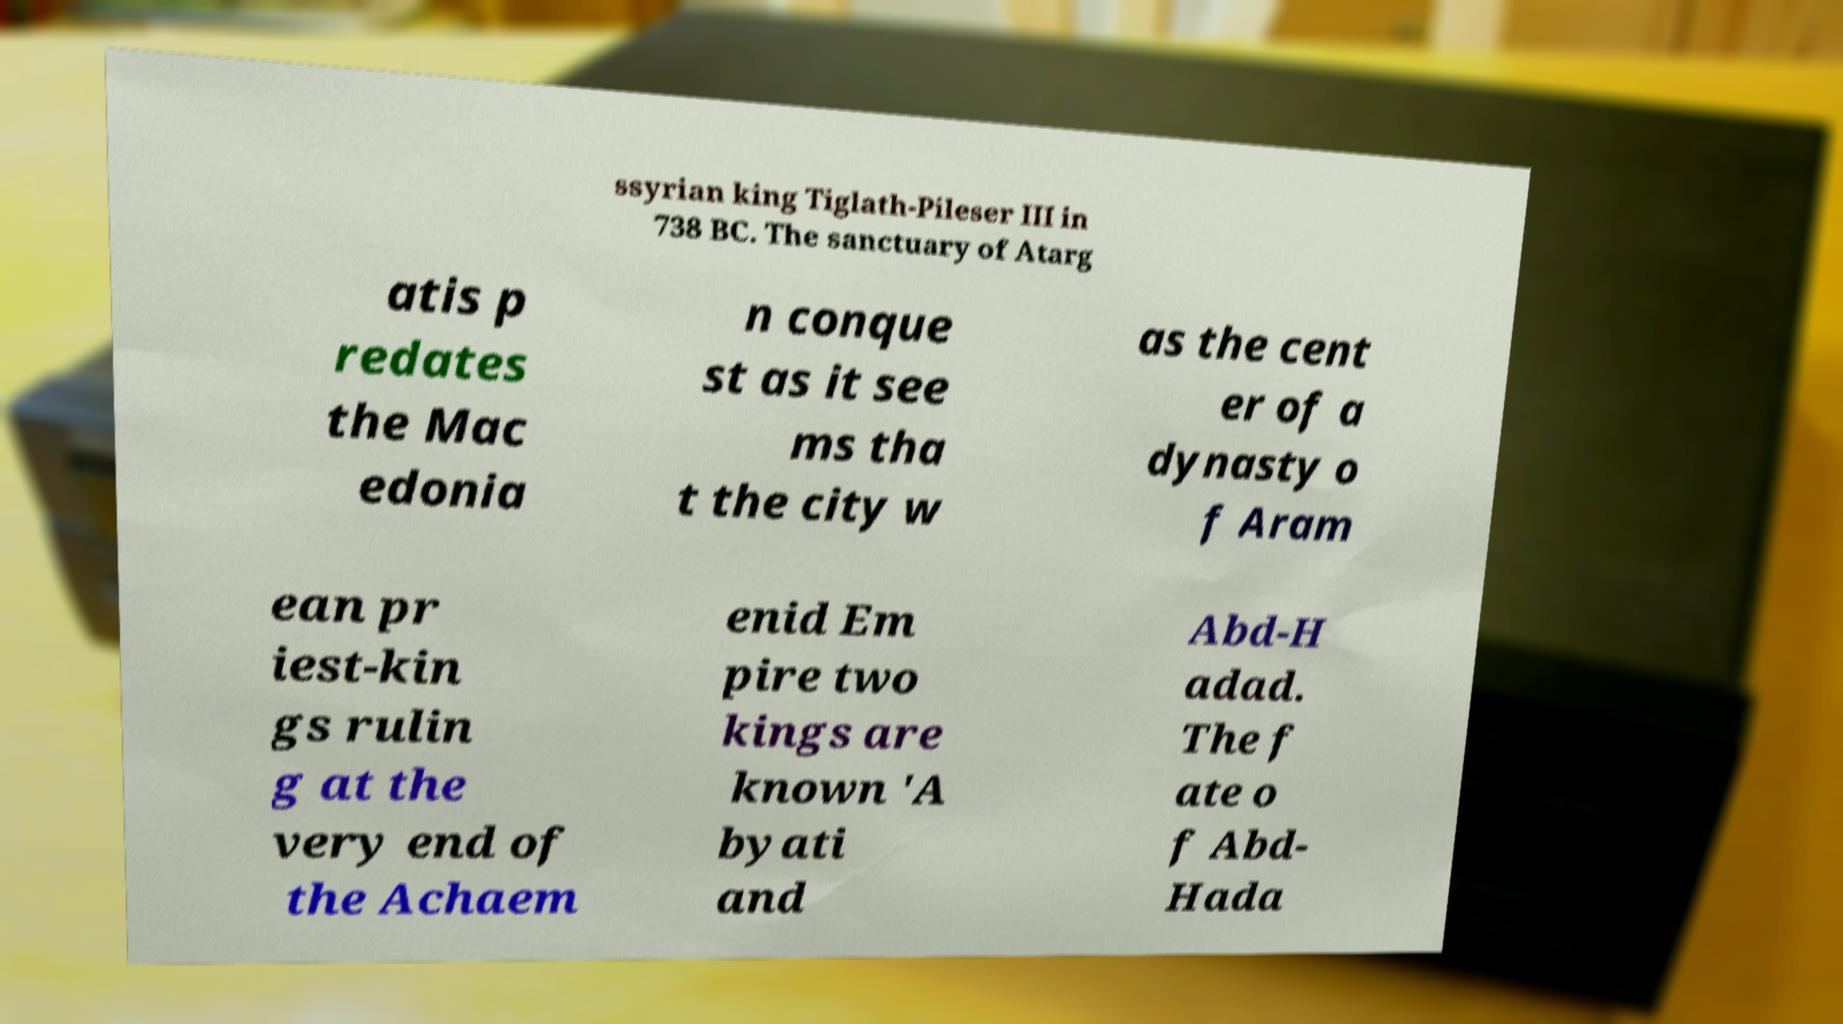For documentation purposes, I need the text within this image transcribed. Could you provide that? ssyrian king Tiglath-Pileser III in 738 BC. The sanctuary of Atarg atis p redates the Mac edonia n conque st as it see ms tha t the city w as the cent er of a dynasty o f Aram ean pr iest-kin gs rulin g at the very end of the Achaem enid Em pire two kings are known 'A byati and Abd-H adad. The f ate o f Abd- Hada 